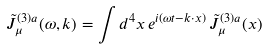<formula> <loc_0><loc_0><loc_500><loc_500>\tilde { J } _ { \mu } ^ { ( 3 ) a } ( \omega , { k } ) = \int d ^ { 4 } x \, e ^ { i ( \omega t - { k } \cdot { x } ) } \, \tilde { J } _ { \mu } ^ { ( 3 ) a } ( x )</formula> 